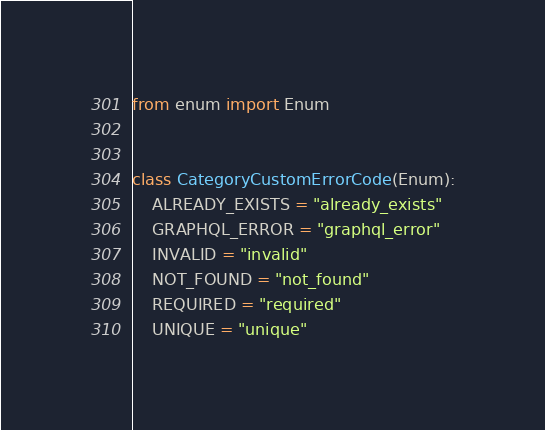<code> <loc_0><loc_0><loc_500><loc_500><_Python_>from enum import Enum


class CategoryCustomErrorCode(Enum):
    ALREADY_EXISTS = "already_exists"
    GRAPHQL_ERROR = "graphql_error"
    INVALID = "invalid"
    NOT_FOUND = "not_found"
    REQUIRED = "required"
    UNIQUE = "unique"
</code> 